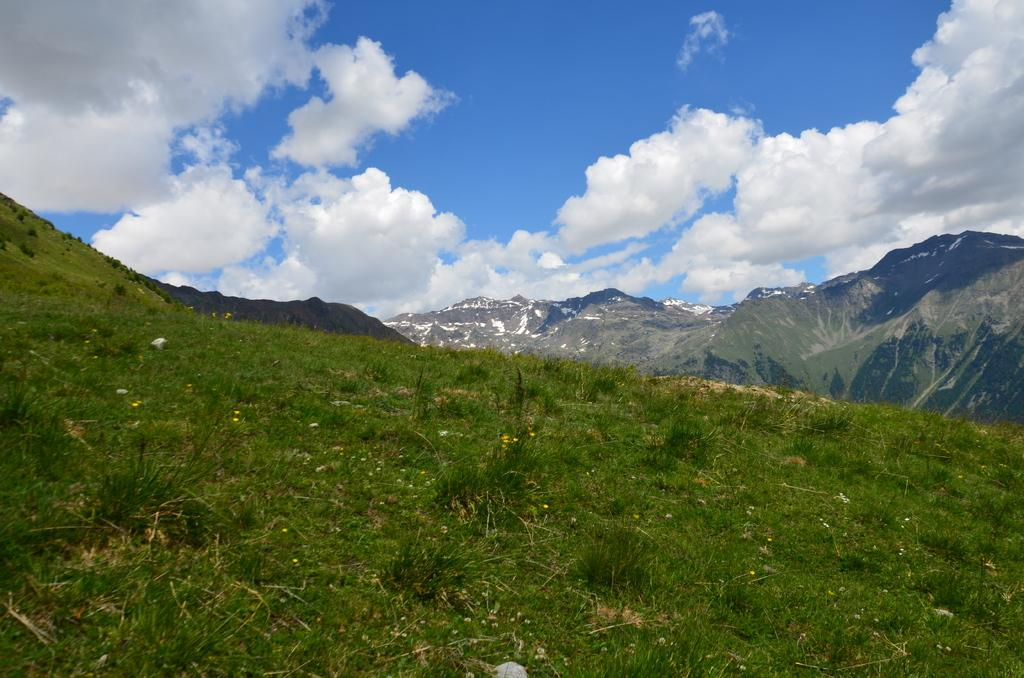What type of vegetation is present in the foreground of the image? There are shrubs and grass in the foreground of the image. What geographical feature is located in the center of the image? There are mountains in the center of the image. How would you describe the weather in the image? The sky is sunny, indicating a clear and likely warm day. What type of lace can be seen on the mountains in the image? There is no lace present on the mountains in the image; they are natural geographical features. What is the tendency of the grass to grow in the image? The facts provided do not give information about the growth rate or tendency of the grass in the image. 